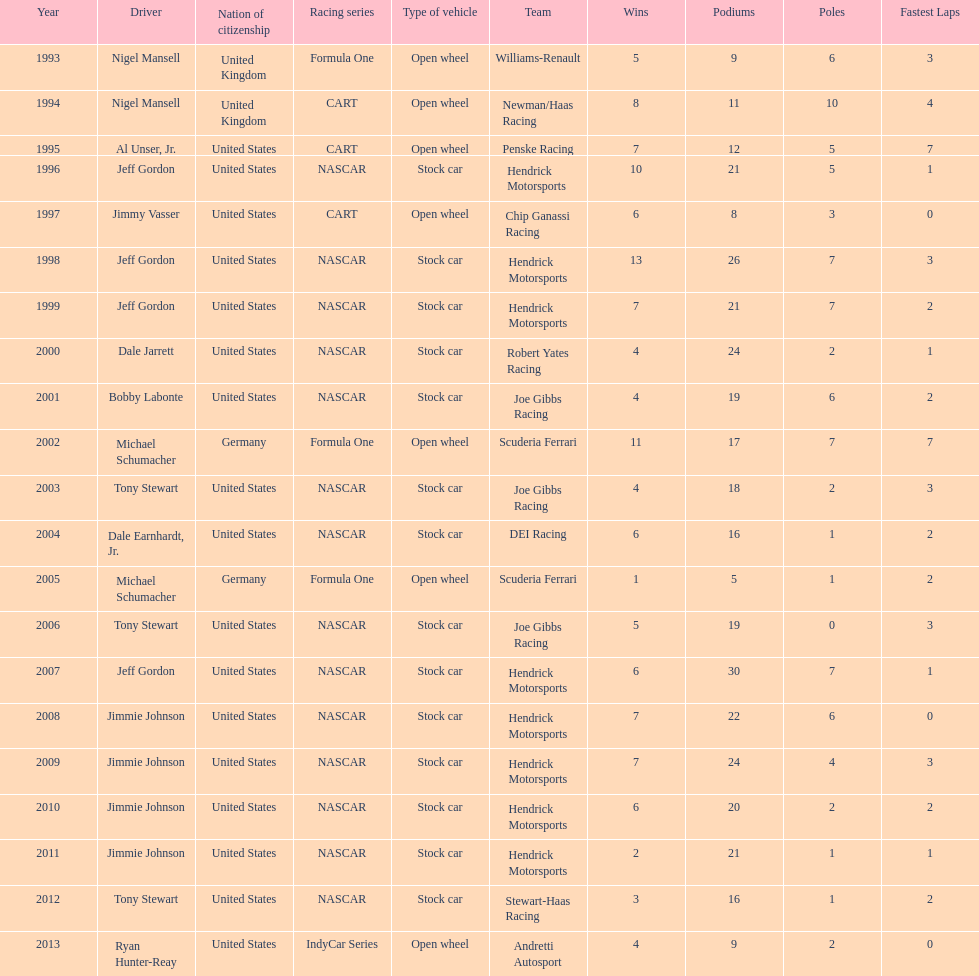Which driver managed to secure four wins in a row? Jimmie Johnson. 